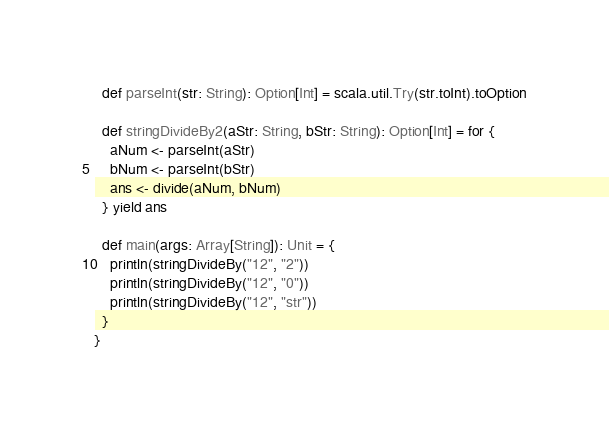<code> <loc_0><loc_0><loc_500><loc_500><_Scala_>  def parseInt(str: String): Option[Int] = scala.util.Try(str.toInt).toOption

  def stringDivideBy2(aStr: String, bStr: String): Option[Int] = for {
    aNum <- parseInt(aStr)
    bNum <- parseInt(bStr)
    ans <- divide(aNum, bNum)
  } yield ans

  def main(args: Array[String]): Unit = {
    println(stringDivideBy("12", "2"))
    println(stringDivideBy("12", "0"))
    println(stringDivideBy("12", "str"))
  }
}


</code> 